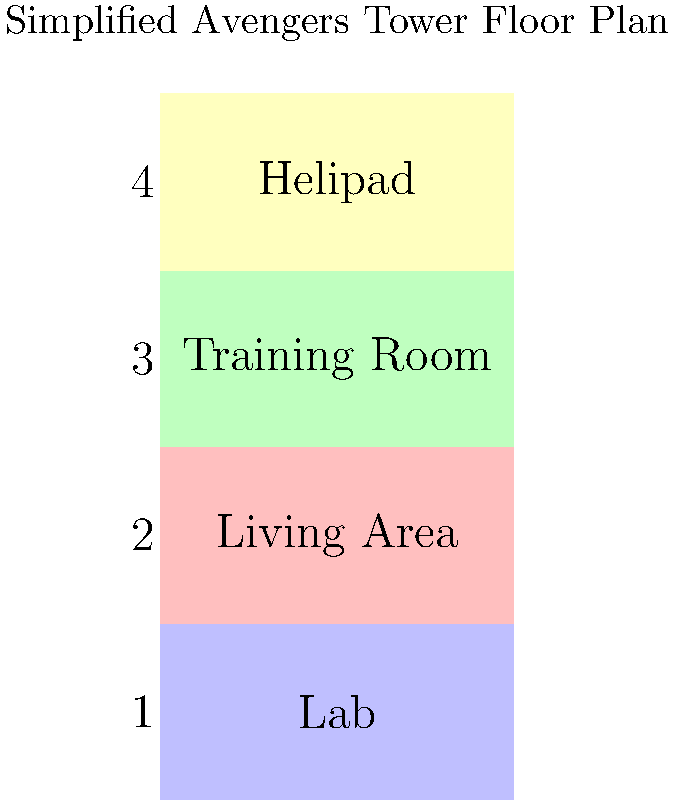Based on the simplified floor plan of Avengers Tower, which floor is directly below the Helipad? To answer this question, let's analyze the floor plan step-by-step:

1. The floor plan shows four levels of Avengers Tower.
2. Each floor is labeled with a number and a function:
   - Floor 1: Lab
   - Floor 2: Living Area
   - Floor 3: Training Room
   - Floor 4: Helipad
3. The floors are stacked vertically, with Floor 1 at the bottom and Floor 4 at the top.
4. The Helipad is clearly labeled on Floor 4, the topmost floor.
5. To find which floor is directly below the Helipad, we need to look at the floor immediately beneath Floor 4.
6. Floor 3 is directly below Floor 4.
7. Floor 3 is labeled as the Training Room.

Therefore, the floor directly below the Helipad is the Training Room floor.
Answer: Training Room 